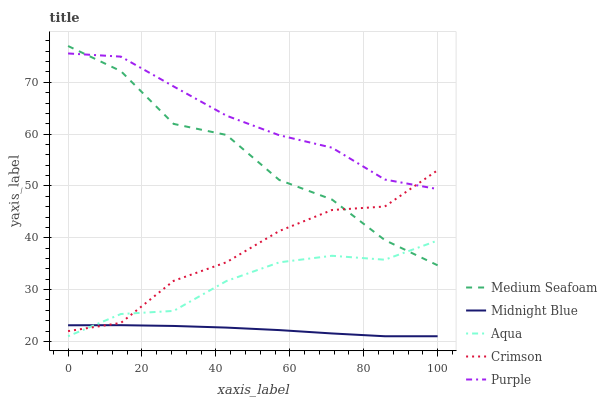Does Midnight Blue have the minimum area under the curve?
Answer yes or no. Yes. Does Purple have the maximum area under the curve?
Answer yes or no. Yes. Does Aqua have the minimum area under the curve?
Answer yes or no. No. Does Aqua have the maximum area under the curve?
Answer yes or no. No. Is Midnight Blue the smoothest?
Answer yes or no. Yes. Is Medium Seafoam the roughest?
Answer yes or no. Yes. Is Purple the smoothest?
Answer yes or no. No. Is Purple the roughest?
Answer yes or no. No. Does Aqua have the lowest value?
Answer yes or no. Yes. Does Purple have the lowest value?
Answer yes or no. No. Does Medium Seafoam have the highest value?
Answer yes or no. Yes. Does Purple have the highest value?
Answer yes or no. No. Is Midnight Blue less than Purple?
Answer yes or no. Yes. Is Medium Seafoam greater than Midnight Blue?
Answer yes or no. Yes. Does Crimson intersect Aqua?
Answer yes or no. Yes. Is Crimson less than Aqua?
Answer yes or no. No. Is Crimson greater than Aqua?
Answer yes or no. No. Does Midnight Blue intersect Purple?
Answer yes or no. No. 